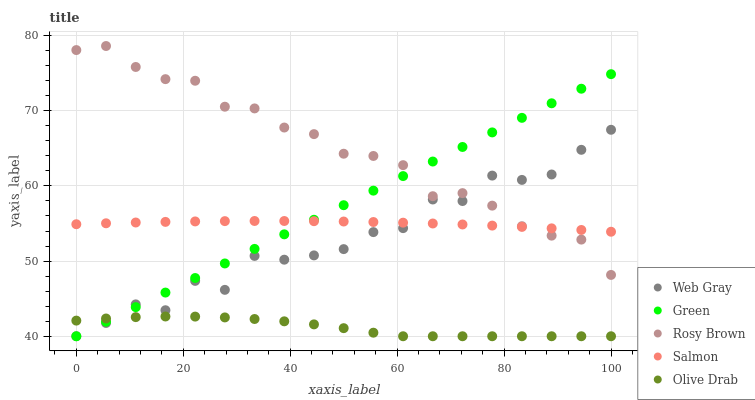Does Olive Drab have the minimum area under the curve?
Answer yes or no. Yes. Does Rosy Brown have the maximum area under the curve?
Answer yes or no. Yes. Does Web Gray have the minimum area under the curve?
Answer yes or no. No. Does Web Gray have the maximum area under the curve?
Answer yes or no. No. Is Green the smoothest?
Answer yes or no. Yes. Is Web Gray the roughest?
Answer yes or no. Yes. Is Rosy Brown the smoothest?
Answer yes or no. No. Is Rosy Brown the roughest?
Answer yes or no. No. Does Web Gray have the lowest value?
Answer yes or no. Yes. Does Rosy Brown have the lowest value?
Answer yes or no. No. Does Rosy Brown have the highest value?
Answer yes or no. Yes. Does Web Gray have the highest value?
Answer yes or no. No. Is Olive Drab less than Rosy Brown?
Answer yes or no. Yes. Is Rosy Brown greater than Olive Drab?
Answer yes or no. Yes. Does Web Gray intersect Olive Drab?
Answer yes or no. Yes. Is Web Gray less than Olive Drab?
Answer yes or no. No. Is Web Gray greater than Olive Drab?
Answer yes or no. No. Does Olive Drab intersect Rosy Brown?
Answer yes or no. No. 